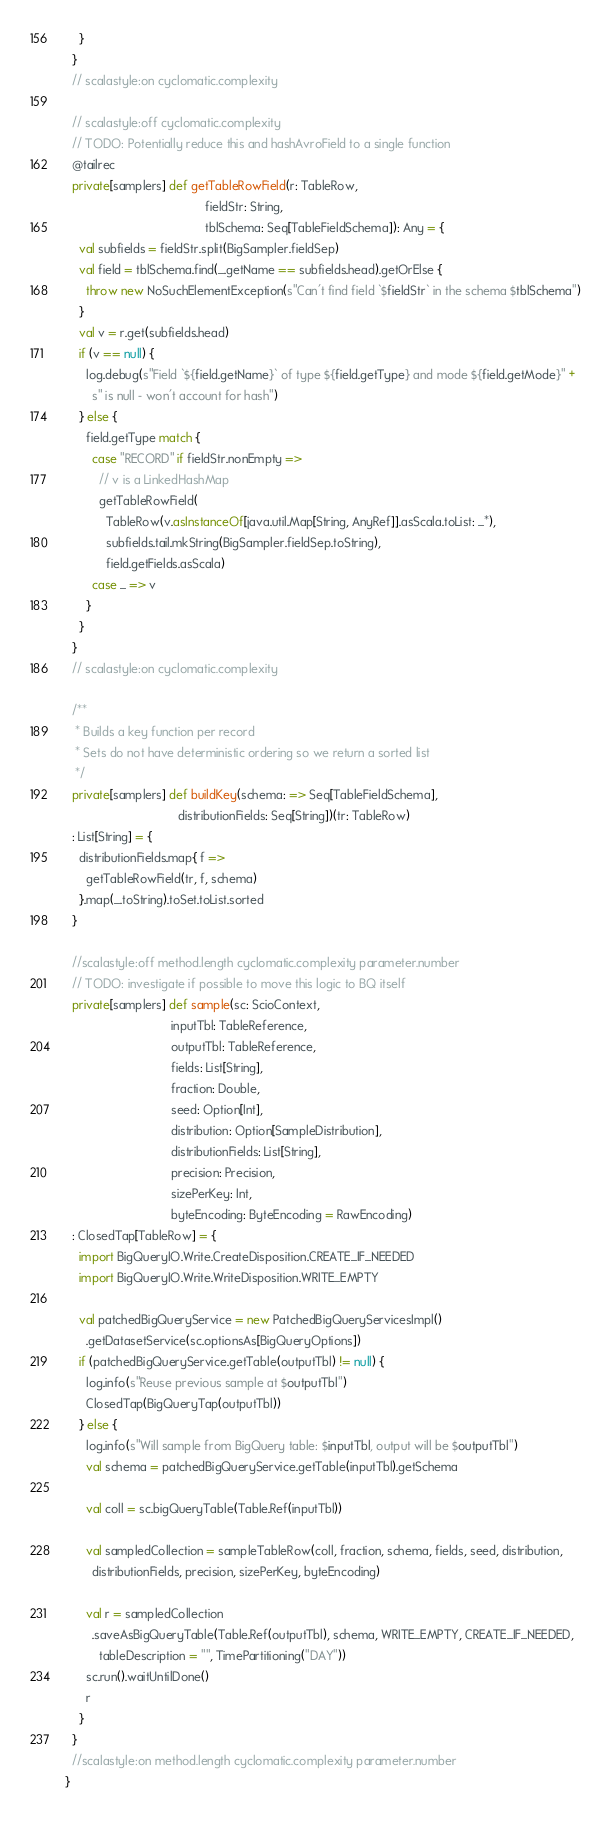Convert code to text. <code><loc_0><loc_0><loc_500><loc_500><_Scala_>    }
  }
  // scalastyle:on cyclomatic.complexity

  // scalastyle:off cyclomatic.complexity
  // TODO: Potentially reduce this and hashAvroField to a single function
  @tailrec
  private[samplers] def getTableRowField(r: TableRow,
                                         fieldStr: String,
                                         tblSchema: Seq[TableFieldSchema]): Any = {
    val subfields = fieldStr.split(BigSampler.fieldSep)
    val field = tblSchema.find(_.getName == subfields.head).getOrElse {
      throw new NoSuchElementException(s"Can't find field `$fieldStr` in the schema $tblSchema")
    }
    val v = r.get(subfields.head)
    if (v == null) {
      log.debug(s"Field `${field.getName}` of type ${field.getType} and mode ${field.getMode}" +
        s" is null - won't account for hash")
    } else {
      field.getType match {
        case "RECORD" if fieldStr.nonEmpty =>
          // v is a LinkedHashMap
          getTableRowField(
            TableRow(v.asInstanceOf[java.util.Map[String, AnyRef]].asScala.toList: _*),
            subfields.tail.mkString(BigSampler.fieldSep.toString),
            field.getFields.asScala)
        case _ => v
      }
    }
  }
  // scalastyle:on cyclomatic.complexity

  /**
   * Builds a key function per record
   * Sets do not have deterministic ordering so we return a sorted list
   */
  private[samplers] def buildKey(schema: => Seq[TableFieldSchema],
                                 distributionFields: Seq[String])(tr: TableRow)
  : List[String] = {
    distributionFields.map{ f =>
      getTableRowField(tr, f, schema)
    }.map(_.toString).toSet.toList.sorted
  }

  //scalastyle:off method.length cyclomatic.complexity parameter.number
  // TODO: investigate if possible to move this logic to BQ itself
  private[samplers] def sample(sc: ScioContext,
                               inputTbl: TableReference,
                               outputTbl: TableReference,
                               fields: List[String],
                               fraction: Double,
                               seed: Option[Int],
                               distribution: Option[SampleDistribution],
                               distributionFields: List[String],
                               precision: Precision,
                               sizePerKey: Int,
                               byteEncoding: ByteEncoding = RawEncoding)
  : ClosedTap[TableRow] = {
    import BigQueryIO.Write.CreateDisposition.CREATE_IF_NEEDED
    import BigQueryIO.Write.WriteDisposition.WRITE_EMPTY

    val patchedBigQueryService = new PatchedBigQueryServicesImpl()
      .getDatasetService(sc.optionsAs[BigQueryOptions])
    if (patchedBigQueryService.getTable(outputTbl) != null) {
      log.info(s"Reuse previous sample at $outputTbl")
      ClosedTap(BigQueryTap(outputTbl))
    } else {
      log.info(s"Will sample from BigQuery table: $inputTbl, output will be $outputTbl")
      val schema = patchedBigQueryService.getTable(inputTbl).getSchema

      val coll = sc.bigQueryTable(Table.Ref(inputTbl))

      val sampledCollection = sampleTableRow(coll, fraction, schema, fields, seed, distribution,
        distributionFields, precision, sizePerKey, byteEncoding)

      val r = sampledCollection
        .saveAsBigQueryTable(Table.Ref(outputTbl), schema, WRITE_EMPTY, CREATE_IF_NEEDED,
          tableDescription = "", TimePartitioning("DAY"))
      sc.run().waitUntilDone()
      r
    }
  }
  //scalastyle:on method.length cyclomatic.complexity parameter.number
}
</code> 